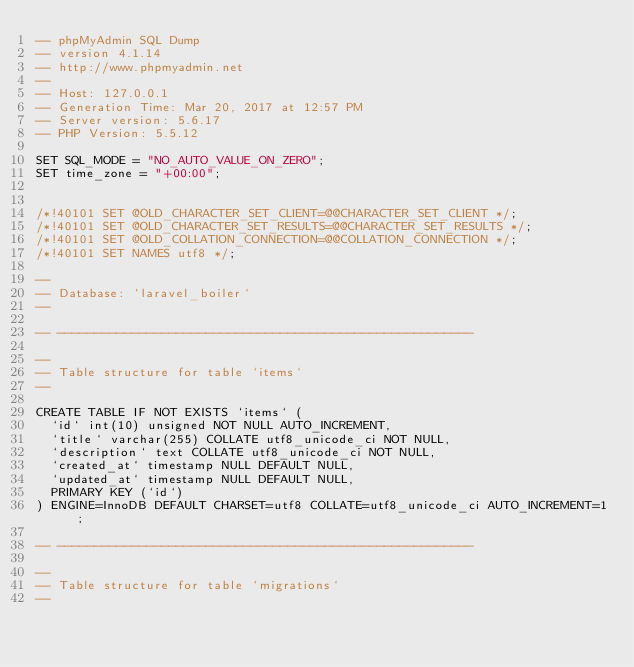<code> <loc_0><loc_0><loc_500><loc_500><_SQL_>-- phpMyAdmin SQL Dump
-- version 4.1.14
-- http://www.phpmyadmin.net
--
-- Host: 127.0.0.1
-- Generation Time: Mar 20, 2017 at 12:57 PM
-- Server version: 5.6.17
-- PHP Version: 5.5.12

SET SQL_MODE = "NO_AUTO_VALUE_ON_ZERO";
SET time_zone = "+00:00";


/*!40101 SET @OLD_CHARACTER_SET_CLIENT=@@CHARACTER_SET_CLIENT */;
/*!40101 SET @OLD_CHARACTER_SET_RESULTS=@@CHARACTER_SET_RESULTS */;
/*!40101 SET @OLD_COLLATION_CONNECTION=@@COLLATION_CONNECTION */;
/*!40101 SET NAMES utf8 */;

--
-- Database: `laravel_boiler`
--

-- --------------------------------------------------------

--
-- Table structure for table `items`
--

CREATE TABLE IF NOT EXISTS `items` (
  `id` int(10) unsigned NOT NULL AUTO_INCREMENT,
  `title` varchar(255) COLLATE utf8_unicode_ci NOT NULL,
  `description` text COLLATE utf8_unicode_ci NOT NULL,
  `created_at` timestamp NULL DEFAULT NULL,
  `updated_at` timestamp NULL DEFAULT NULL,
  PRIMARY KEY (`id`)
) ENGINE=InnoDB DEFAULT CHARSET=utf8 COLLATE=utf8_unicode_ci AUTO_INCREMENT=1 ;

-- --------------------------------------------------------

--
-- Table structure for table `migrations`
--
</code> 